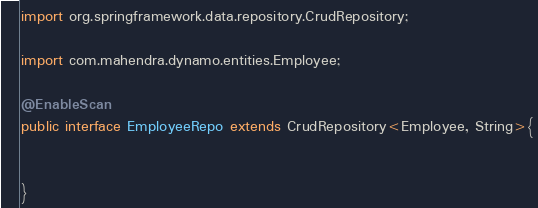<code> <loc_0><loc_0><loc_500><loc_500><_Java_>import org.springframework.data.repository.CrudRepository;

import com.mahendra.dynamo.entities.Employee;

@EnableScan
public interface EmployeeRepo extends CrudRepository<Employee, String>{
	
	
}
</code> 